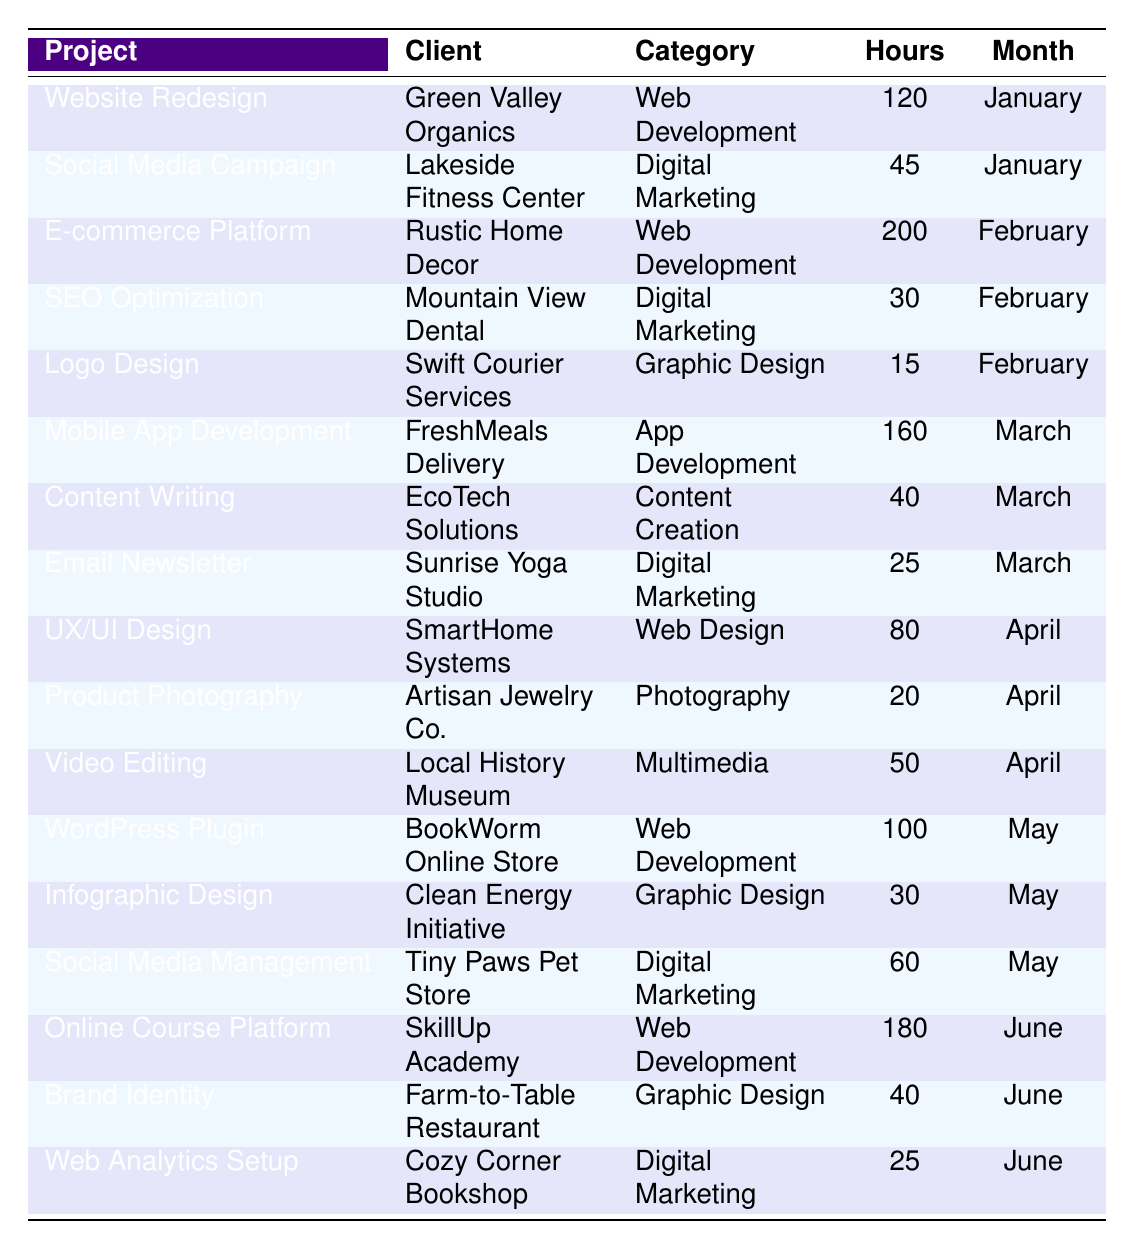What is the total number of hours spent on the "Web Development" category? From the table, the projects in the "Web Development" category are: Website Redesign (120 hours), E-commerce Platform (200 hours), WordPress Plugin (100 hours), and Online Course Platform (180 hours). Adding these together: 120 + 200 + 100 + 180 = 600 hours.
Answer: 600 hours Which client had the highest number of hours spent on their project? The projects and hours spent are: Green Valley Organics (120), Rustic Home Decor (200), FreshMeals Delivery (160), and SkillUp Academy (180). The maximum is 200 hours for Rustic Home Decor.
Answer: Rustic Home Decor How many projects fall under the "Digital Marketing" category? The "Digital Marketing" projects listed are: Social Media Campaign, SEO Optimization, Email Newsletter, Social Media Management, and Web Analytics Setup. Counting these gives us a total of 5 projects.
Answer: 5 projects What is the average number of hours spent on "Graphic Design" projects? The "Graphic Design" projects are Logo Design (15 hours), Infographic Design (30 hours), and Brand Identity (40 hours). To find the average, we sum these: 15 + 30 + 40 = 85, then divide by the number of projects (which is 3): 85/3 ≈ 28.33 hours.
Answer: 28.33 hours Did you spend more hours on "App Development" or "Photography" projects? The "App Development" project (Mobile App Development) has 160 hours, whereas the "Photography" project (Product Photography) has 20 hours. Since 160 > 20, more hours were spent on App Development.
Answer: Yes What is the total number of hours worked in March? In March, the projects were Mobile App Development (160), Content Writing (40), and Email Newsletter (25). Adding those gives: 160 + 40 + 25 = 225 hours worked in March.
Answer: 225 hours Which category had the least hours spent across all projects? The categories and their respective hours are as follows: Digital Marketing (205), Web Development (600), Graphic Design (85), App Development (160), Photography (20), Content Creation (40), and Multimedia (50). The minimum is for Photography with 20 hours.
Answer: Photography How many hours were spent on "Web Development" in total compared to "Digital Marketing"? Total hours for "Web Development" are 600 hours (from earlier calculations), and for "Digital Marketing", they sum to 205 hours (Social Media Campaign 45 + SEO Optimization 30 + Email Newsletter 25 + Social Media Management 60 + Web Analytics Setup 25). Hence, 600 > 205, indicating more time was allocated to Web Development.
Answer: Yes What was the second most time-consuming project and how many hours did it take? The projects by hours are: E-commerce Platform (200), Online Course Platform (180), Mobile App Development (160), Website Redesign (120), and so on. The second most time-consuming is Online Course Platform at 180 hours.
Answer: Online Course Platform, 180 hours Are there any projects that were completed in both January and June? Reviewing January's projects: Website Redesign and Social Media Campaign; and June's: Online Course Platform, Brand Identity, and Web Analytics Setup, we find no common projects in both months.
Answer: No 